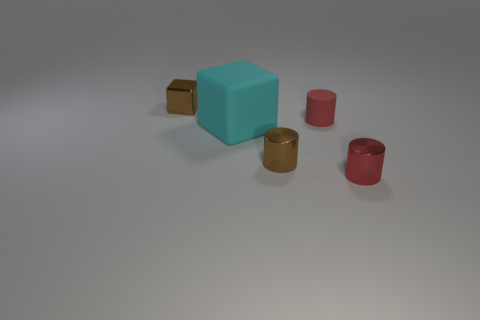Are there any tiny metal cylinders on the left side of the tiny red rubber cylinder?
Give a very brief answer. Yes. Is the number of tiny brown things that are to the right of the red metal object the same as the number of big cyan rubber things that are to the left of the big cyan cube?
Offer a very short reply. Yes. There is a red cylinder behind the small red metallic thing; is its size the same as the brown shiny thing behind the cyan matte thing?
Make the answer very short. Yes. What shape is the brown metallic thing that is right of the tiny brown metallic thing that is behind the tiny brown metal object that is in front of the brown cube?
Offer a terse response. Cylinder. Is there any other thing that is the same material as the tiny brown cube?
Give a very brief answer. Yes. The brown thing that is the same shape as the large cyan matte thing is what size?
Your answer should be compact. Small. What color is the thing that is both to the left of the brown metallic cylinder and behind the cyan matte object?
Your answer should be compact. Brown. Does the cyan object have the same material as the tiny brown thing in front of the small brown metallic block?
Your answer should be very brief. No. Is the number of tiny brown metal cylinders that are behind the brown block less than the number of cyan blocks?
Provide a succinct answer. Yes. What number of other things are there of the same shape as the red metallic thing?
Provide a short and direct response. 2. 